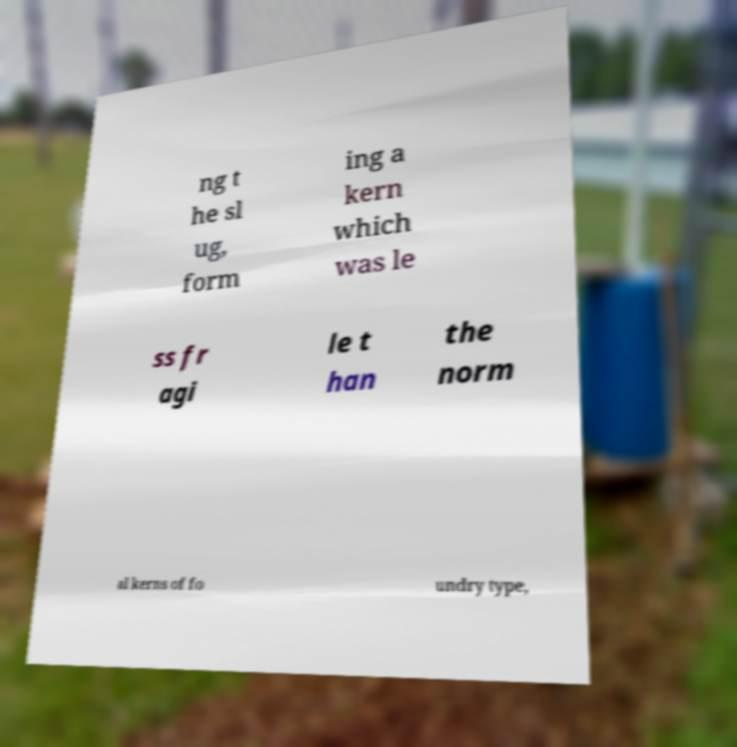Can you accurately transcribe the text from the provided image for me? ng t he sl ug, form ing a kern which was le ss fr agi le t han the norm al kerns of fo undry type, 